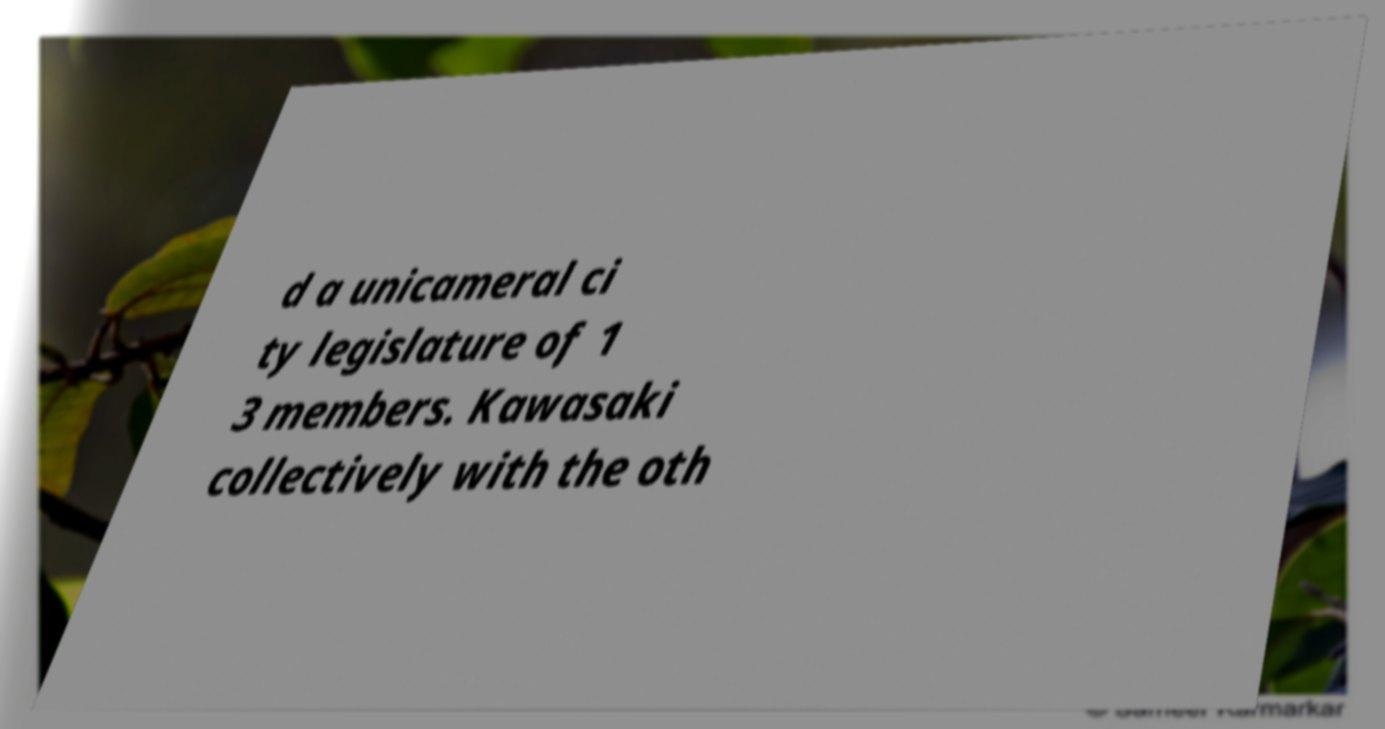Could you assist in decoding the text presented in this image and type it out clearly? d a unicameral ci ty legislature of 1 3 members. Kawasaki collectively with the oth 